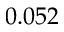<formula> <loc_0><loc_0><loc_500><loc_500>0 . 0 5 2</formula> 